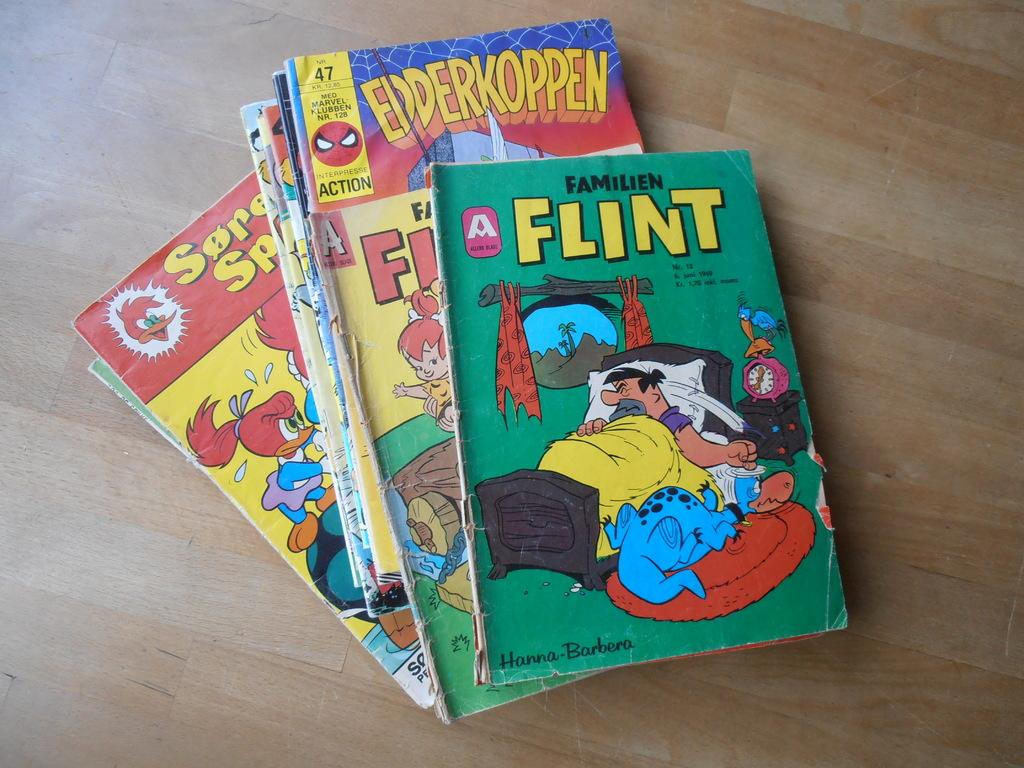<image>
Offer a succinct explanation of the picture presented. Several other books are stacked under a book called Flint. 